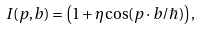Convert formula to latex. <formula><loc_0><loc_0><loc_500><loc_500>I ( { p } , { b } ) = \left ( 1 + \eta \cos ( { p \cdot b } / \hbar { ) } \right ) ,</formula> 